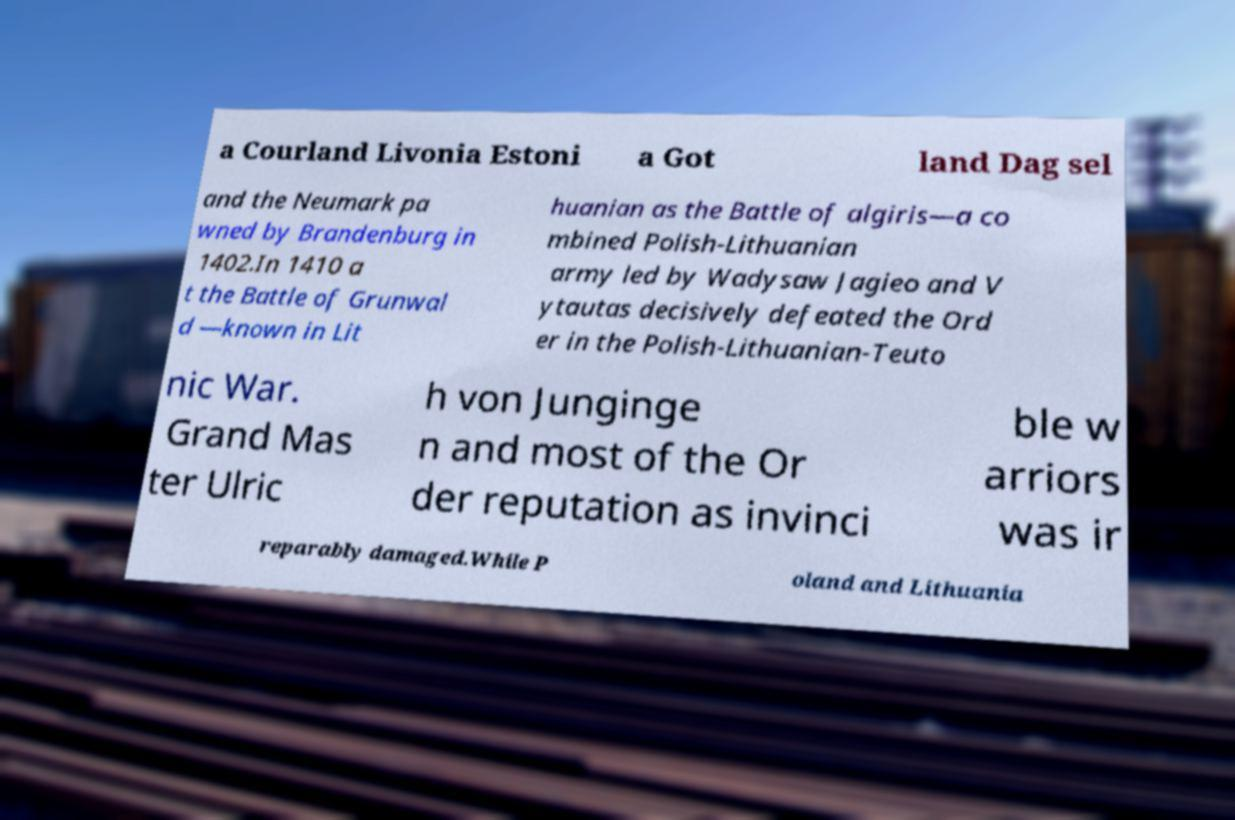Can you accurately transcribe the text from the provided image for me? a Courland Livonia Estoni a Got land Dag sel and the Neumark pa wned by Brandenburg in 1402.In 1410 a t the Battle of Grunwal d —known in Lit huanian as the Battle of algiris—a co mbined Polish-Lithuanian army led by Wadysaw Jagieo and V ytautas decisively defeated the Ord er in the Polish-Lithuanian-Teuto nic War. Grand Mas ter Ulric h von Junginge n and most of the Or der reputation as invinci ble w arriors was ir reparably damaged.While P oland and Lithuania 